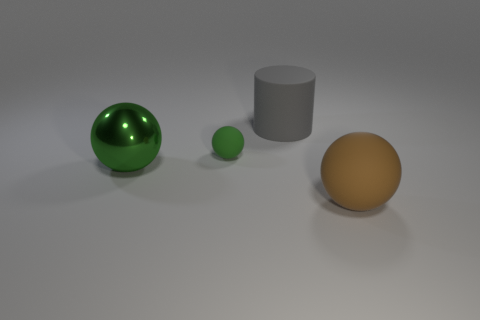Add 2 gray things. How many objects exist? 6 Subtract all matte balls. How many balls are left? 1 Subtract all green spheres. How many spheres are left? 1 Subtract all cyan balls. Subtract all green cubes. How many balls are left? 3 Subtract all purple cylinders. How many gray balls are left? 0 Subtract all yellow metallic cylinders. Subtract all large rubber things. How many objects are left? 2 Add 2 big things. How many big things are left? 5 Add 2 cyan shiny blocks. How many cyan shiny blocks exist? 2 Subtract 2 green balls. How many objects are left? 2 Subtract all spheres. How many objects are left? 1 